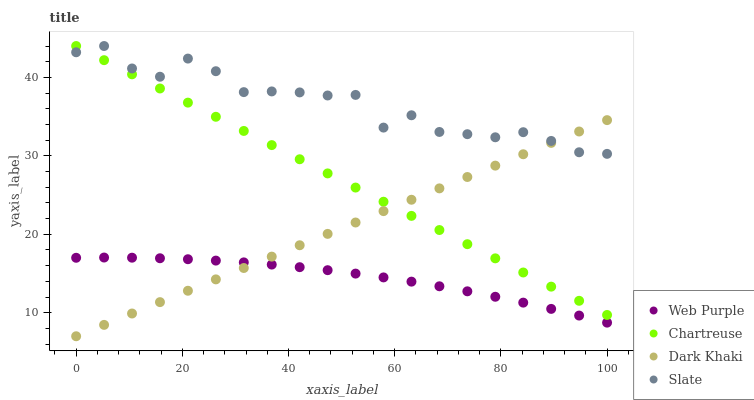Does Web Purple have the minimum area under the curve?
Answer yes or no. Yes. Does Slate have the maximum area under the curve?
Answer yes or no. Yes. Does Slate have the minimum area under the curve?
Answer yes or no. No. Does Web Purple have the maximum area under the curve?
Answer yes or no. No. Is Dark Khaki the smoothest?
Answer yes or no. Yes. Is Slate the roughest?
Answer yes or no. Yes. Is Web Purple the smoothest?
Answer yes or no. No. Is Web Purple the roughest?
Answer yes or no. No. Does Dark Khaki have the lowest value?
Answer yes or no. Yes. Does Web Purple have the lowest value?
Answer yes or no. No. Does Chartreuse have the highest value?
Answer yes or no. Yes. Does Web Purple have the highest value?
Answer yes or no. No. Is Web Purple less than Slate?
Answer yes or no. Yes. Is Chartreuse greater than Web Purple?
Answer yes or no. Yes. Does Slate intersect Chartreuse?
Answer yes or no. Yes. Is Slate less than Chartreuse?
Answer yes or no. No. Is Slate greater than Chartreuse?
Answer yes or no. No. Does Web Purple intersect Slate?
Answer yes or no. No. 